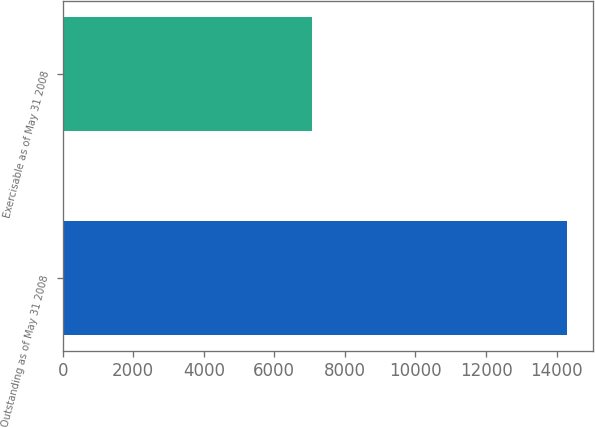Convert chart. <chart><loc_0><loc_0><loc_500><loc_500><bar_chart><fcel>Outstanding as of May 31 2008<fcel>Exercisable as of May 31 2008<nl><fcel>14308<fcel>7068<nl></chart> 